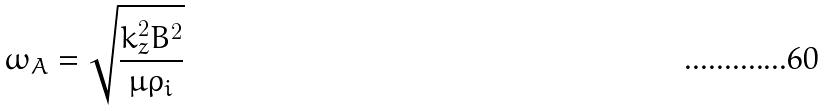Convert formula to latex. <formula><loc_0><loc_0><loc_500><loc_500>\omega _ { A } = \sqrt { \frac { k _ { z } ^ { 2 } B ^ { 2 } } { \mu \rho _ { i } } }</formula> 